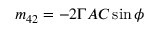Convert formula to latex. <formula><loc_0><loc_0><loc_500><loc_500>m _ { 4 2 } = - 2 \Gamma A C \sin \phi</formula> 